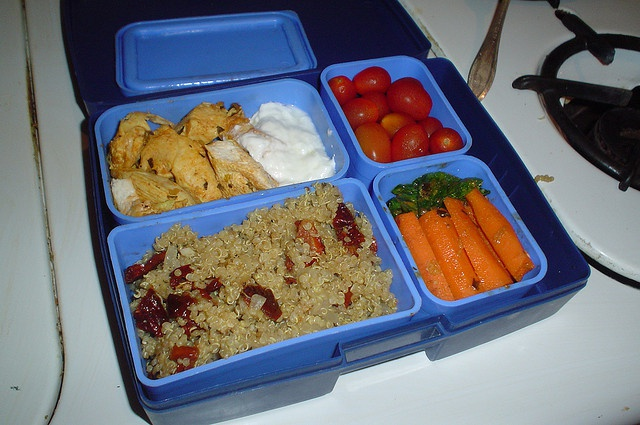Describe the objects in this image and their specific colors. I can see bowl in gray, olive, blue, and maroon tones, bowl in gray, olive, lightgray, and tan tones, bowl in gray, red, and blue tones, bowl in gray, maroon, and blue tones, and carrot in gray, red, brown, and salmon tones in this image. 